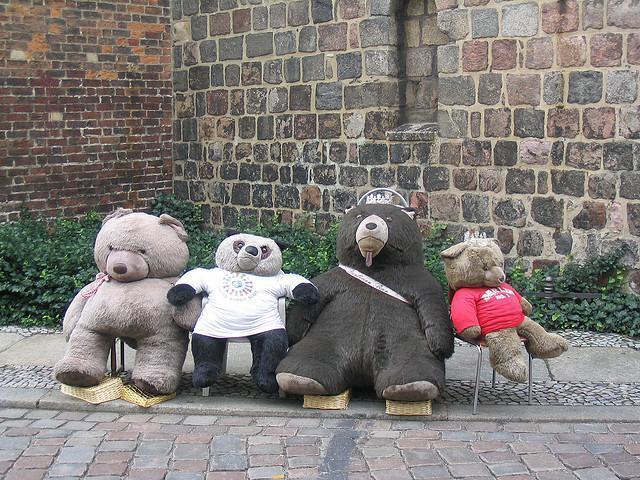How many bears?
Give a very brief answer. 4. How many of the teddy bears are wearing clothing?
Give a very brief answer. 2. How many bears are there?
Give a very brief answer. 4. How many teddy bears can you see?
Give a very brief answer. 4. 